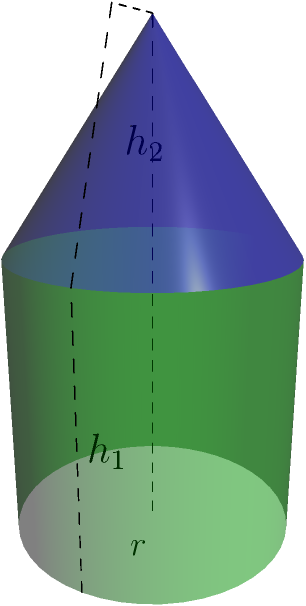As an economist analyzing resource utilization in manufacturing, you encounter a composite solid formed by a cylinder with a cone on top. The cylinder has a radius of 2 meters and a height of 4 meters, while the cone has the same base radius as the cylinder and a height of 3 meters. Calculate the total volume of this composite solid, considering the efficient use of materials in production. Express your answer in cubic meters, rounded to two decimal places. To calculate the total volume of the composite solid, we need to sum the volumes of the cylinder and the cone:

1. Volume of cylinder:
   $$V_{cylinder} = \pi r^2 h_1$$
   where $r$ is the radius and $h_1$ is the height of the cylinder.
   $$V_{cylinder} = \pi (2)^2 (4) = 16\pi \approx 50.27 \text{ m}^3$$

2. Volume of cone:
   $$V_{cone} = \frac{1}{3}\pi r^2 h_2$$
   where $r$ is the radius of the base and $h_2$ is the height of the cone.
   $$V_{cone} = \frac{1}{3}\pi (2)^2 (3) = 4\pi \approx 12.57 \text{ m}^3$$

3. Total volume:
   $$V_{total} = V_{cylinder} + V_{cone}$$
   $$V_{total} = 16\pi + 4\pi = 20\pi \approx 62.83 \text{ m}^3$$

Rounding to two decimal places: 62.83 m³
Answer: 62.83 m³ 